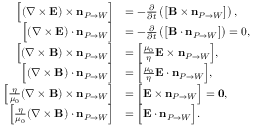Convert formula to latex. <formula><loc_0><loc_0><loc_500><loc_500>\begin{array} { r l } { { \left [ } ( \nabla \times { \mathbf E } ) \times n _ { P \rightarrow W } { \right ] } } & { = - \frac { \partial } { \partial t } \left ( { \left [ } { \mathbf B } \times n _ { P \rightarrow W } { \right ] } \right ) , } \\ { { \left [ } ( \nabla \times { \mathbf E } ) \cdot n _ { P \rightarrow W } { \right ] } } & { = - \frac { \partial } { \partial t } \left ( { \left [ } { \mathbf B } \cdot n _ { P \rightarrow W } { \right ] } \right ) = { 0 } , } \\ { { \left [ } ( \nabla \times { \mathbf B } ) \times n _ { P \rightarrow W } { \right ] } } & { = { \left [ } \frac { \mu _ { 0 } } { \eta } { \mathbf E } \times n _ { P \rightarrow W } { \right ] } , } \\ { { \left [ } ( \nabla \times { \mathbf B } ) \cdot n _ { P \rightarrow W } { \right ] } } & { = { \left [ } \frac { \mu _ { 0 } } { \eta } { \mathbf E } \cdot n _ { P \rightarrow W } { \right ] } , } \\ { { \left [ } \frac { \eta } { \mu _ { 0 } } ( \nabla \times { \mathbf B } ) \times n _ { P \rightarrow W } { \right ] } } & { = { \left [ } { \mathbf E } \times n _ { P \rightarrow W } { \right ] } = 0 , } \\ { { \left [ } \frac { \eta } { \mu _ { 0 } } ( \nabla \times { \mathbf B } ) \cdot n _ { P \rightarrow W } { \right ] } } & { = { \left [ } { \mathbf E } \cdot n _ { P \rightarrow W } { \right ] } . } \end{array}</formula> 